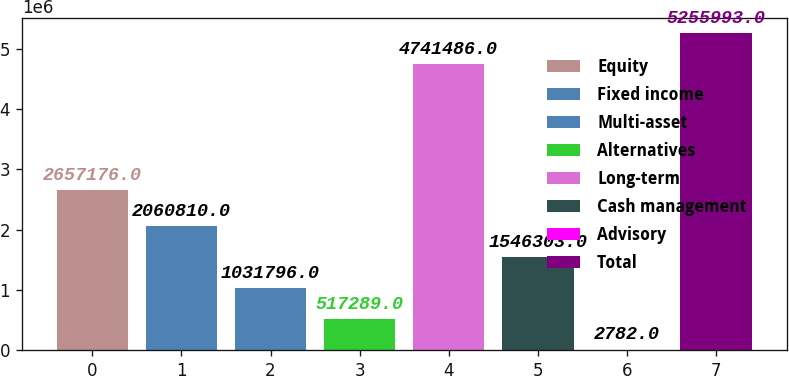Convert chart. <chart><loc_0><loc_0><loc_500><loc_500><bar_chart><fcel>Equity<fcel>Fixed income<fcel>Multi-asset<fcel>Alternatives<fcel>Long-term<fcel>Cash management<fcel>Advisory<fcel>Total<nl><fcel>2.65718e+06<fcel>2.06081e+06<fcel>1.0318e+06<fcel>517289<fcel>4.74149e+06<fcel>1.5463e+06<fcel>2782<fcel>5.25599e+06<nl></chart> 